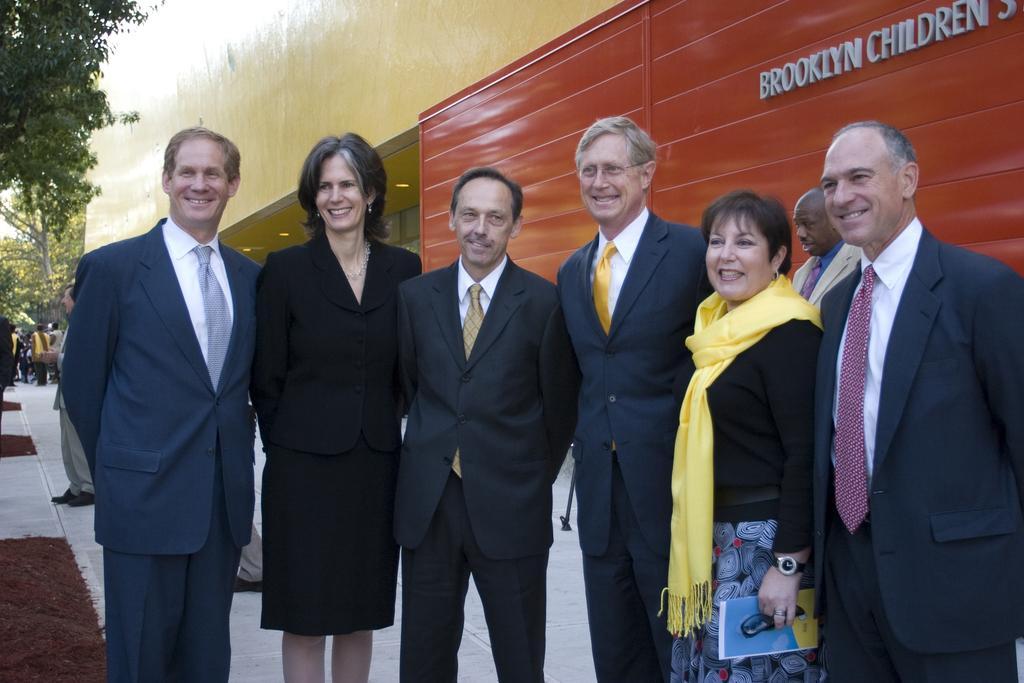Could you give a brief overview of what you see in this image? In this image, we can see people standing and smiling and some are wearing ties and one of them is wearing a scarf and holding a paper. In the background, there are trees and we can see a building and a board and lights and we can see some people. At the bottom, there is floor and sand. 